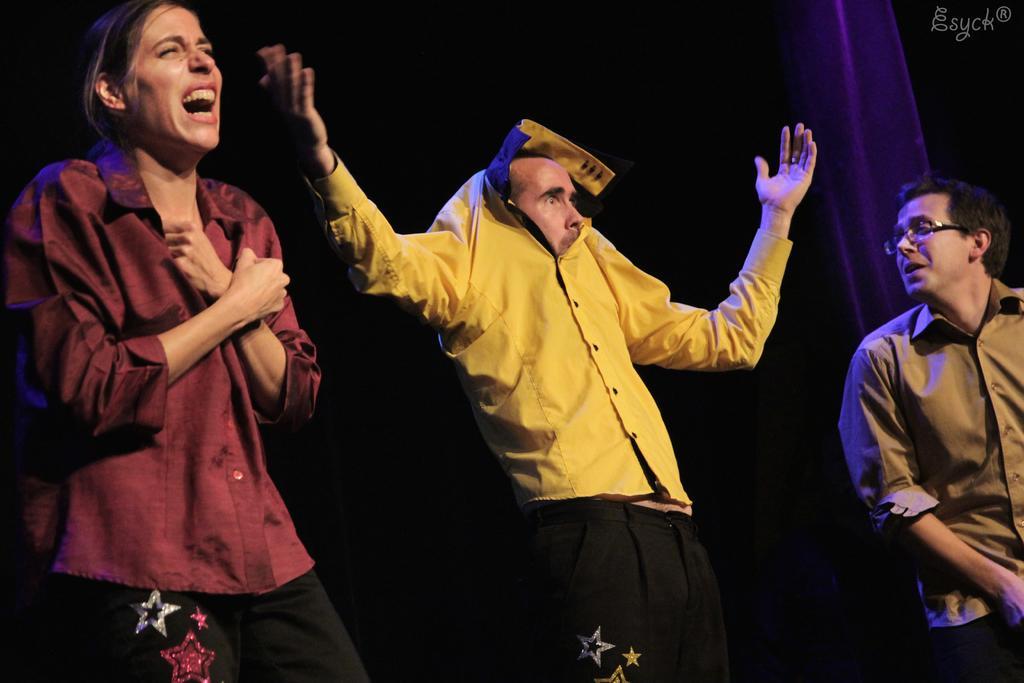How would you summarize this image in a sentence or two? We can see a woman on the left side of the image, she is wearing red color shirt and there is a guy in the middle of the image, he is wearing yellow color shirt, raised his hands into the air and this guy and this women are wearing similar kind of pants. There is another guy on the right side of the image who is wearing specs. we can see certain kind of thing in the background. 